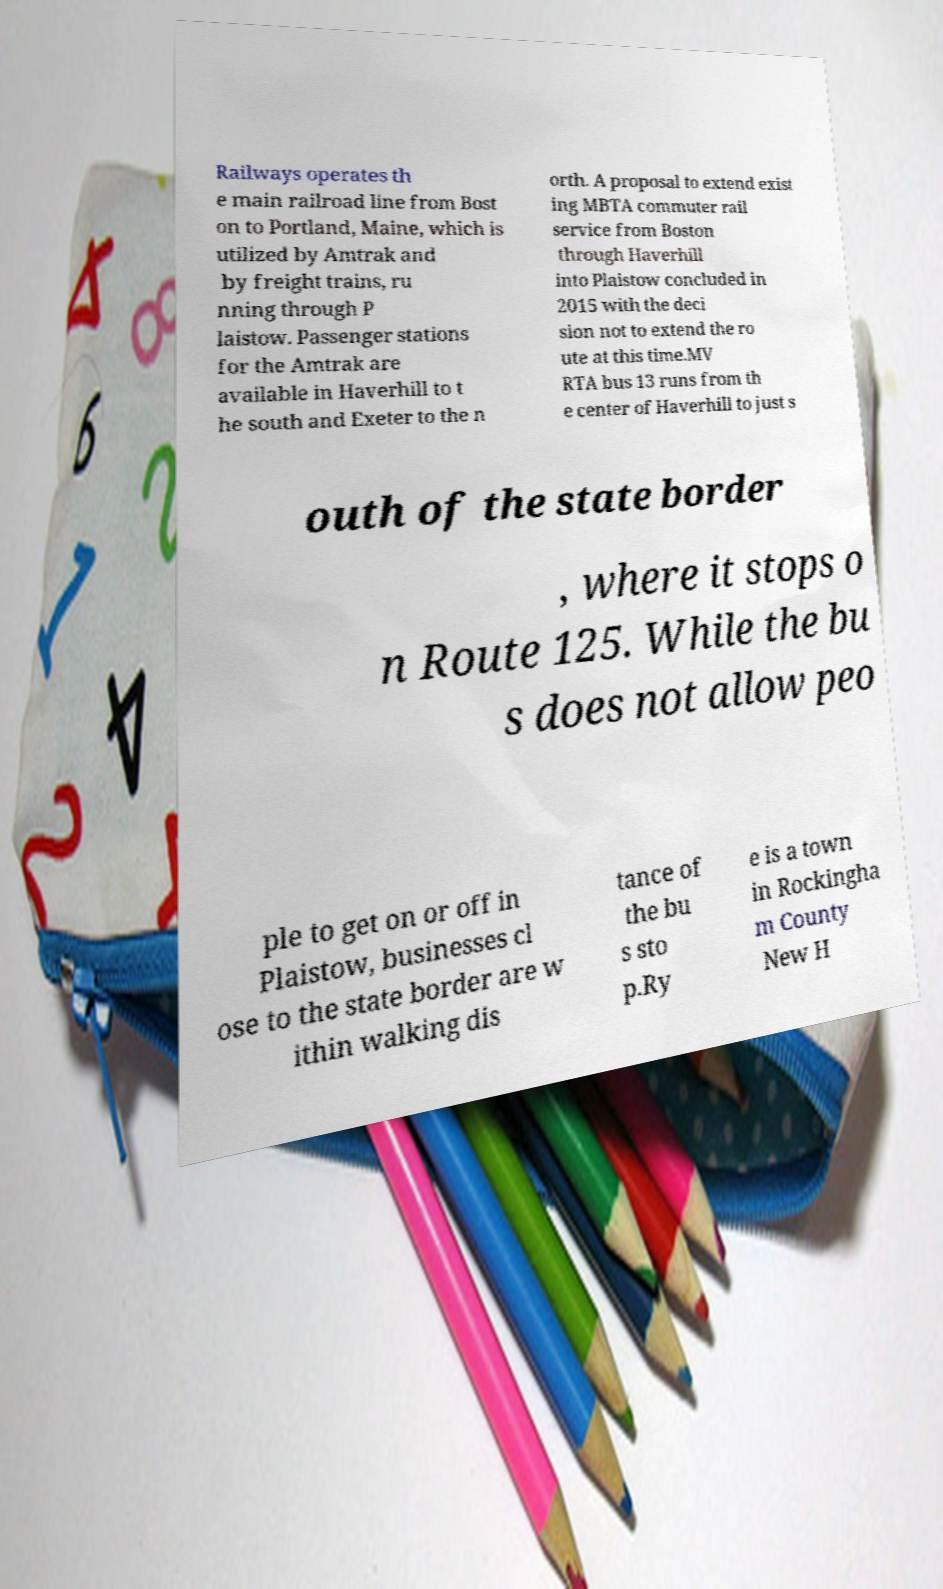Could you assist in decoding the text presented in this image and type it out clearly? Railways operates th e main railroad line from Bost on to Portland, Maine, which is utilized by Amtrak and by freight trains, ru nning through P laistow. Passenger stations for the Amtrak are available in Haverhill to t he south and Exeter to the n orth. A proposal to extend exist ing MBTA commuter rail service from Boston through Haverhill into Plaistow concluded in 2015 with the deci sion not to extend the ro ute at this time.MV RTA bus 13 runs from th e center of Haverhill to just s outh of the state border , where it stops o n Route 125. While the bu s does not allow peo ple to get on or off in Plaistow, businesses cl ose to the state border are w ithin walking dis tance of the bu s sto p.Ry e is a town in Rockingha m County New H 